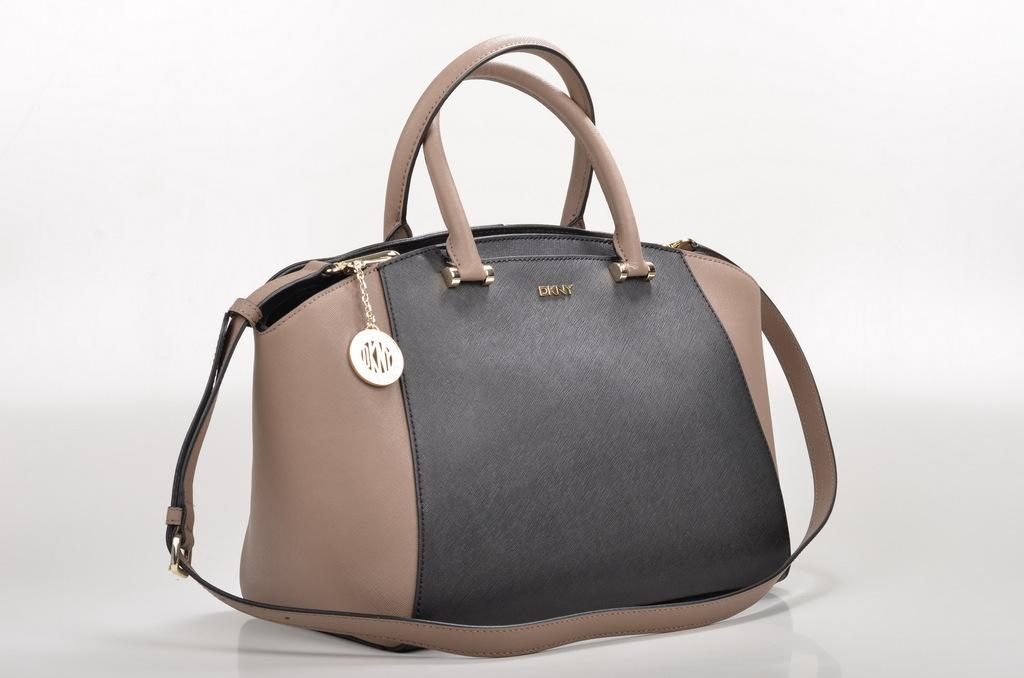What type of accessory is present in the picture? There is a handbag in the picture. Can you describe the color of the handbag? The handbag is brown and black in color. What features does the handbag have? The handbag has a belt, a handle, and a key chain. What is the color of the key chain? The key chain is gold in color. How many tents are set up next to the handbag in the image? There are no tents present in the image; it only features a handbag. What type of cheese is being used as a decoration on the handbag? There is no cheese present in the image; it only features a handbag with a belt, handle, and key chain. 